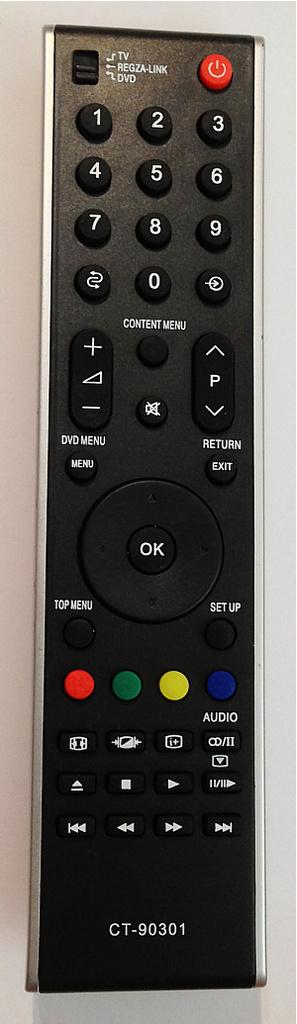<image>
Create a compact narrative representing the image presented. A emote control is labeled with the model number of CT-90301. 